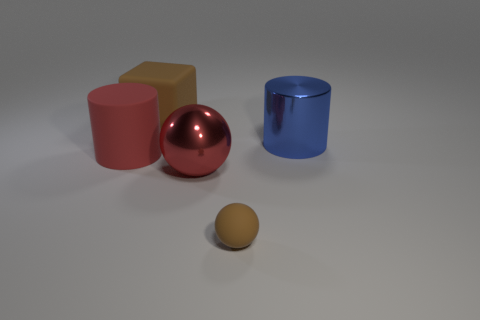Does the object that is on the left side of the matte cube have the same size as the large red shiny sphere?
Give a very brief answer. Yes. What is the color of the sphere that is made of the same material as the blue object?
Your answer should be very brief. Red. Is there anything else that is the same size as the brown ball?
Your answer should be very brief. No. What number of rubber cylinders are behind the large red metallic thing?
Your answer should be compact. 1. There is a large ball that is on the left side of the big blue thing; is it the same color as the large matte thing that is in front of the blue shiny thing?
Your answer should be compact. Yes. What color is the other big object that is the same shape as the big blue thing?
Your answer should be compact. Red. Are there any other things that have the same shape as the big brown object?
Give a very brief answer. No. There is a red object that is on the left side of the big red shiny object; is it the same shape as the large matte thing that is behind the large blue metal cylinder?
Make the answer very short. No. Is the size of the red sphere the same as the brown thing that is behind the brown rubber ball?
Keep it short and to the point. Yes. Are there more gray objects than large red matte cylinders?
Offer a very short reply. No. 